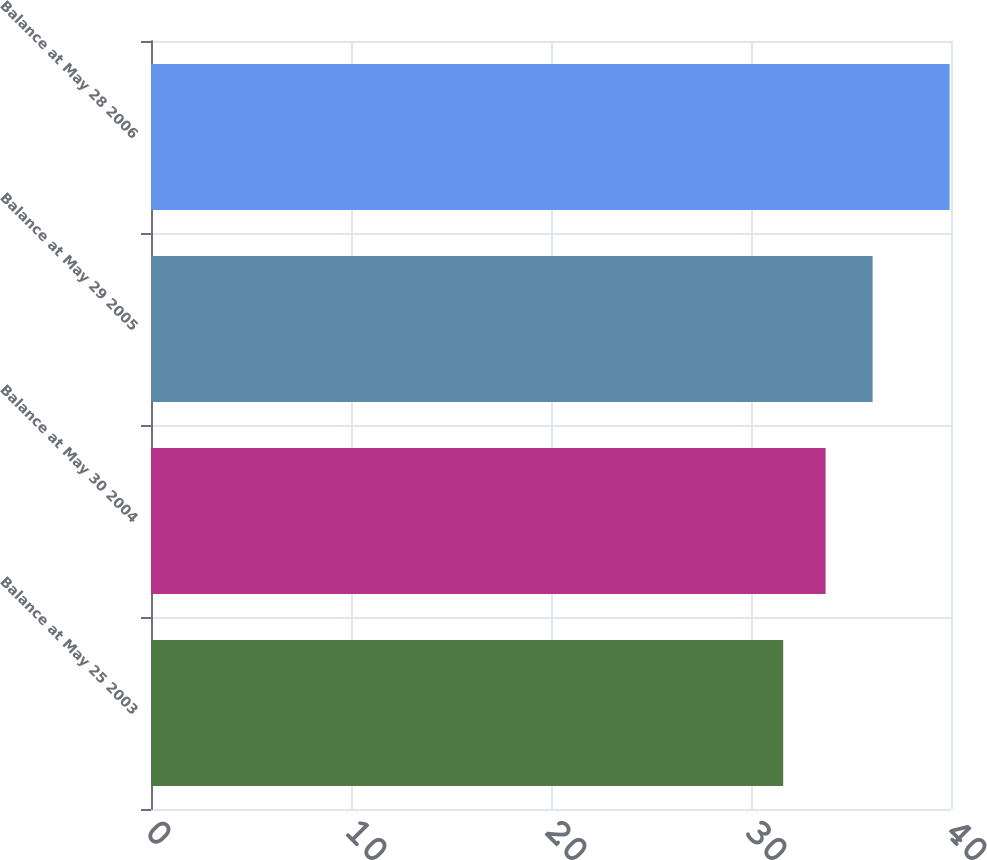Convert chart. <chart><loc_0><loc_0><loc_500><loc_500><bar_chart><fcel>Balance at May 25 2003<fcel>Balance at May 30 2004<fcel>Balance at May 29 2005<fcel>Balance at May 28 2006<nl><fcel>31.61<fcel>33.73<fcel>36.08<fcel>39.93<nl></chart> 